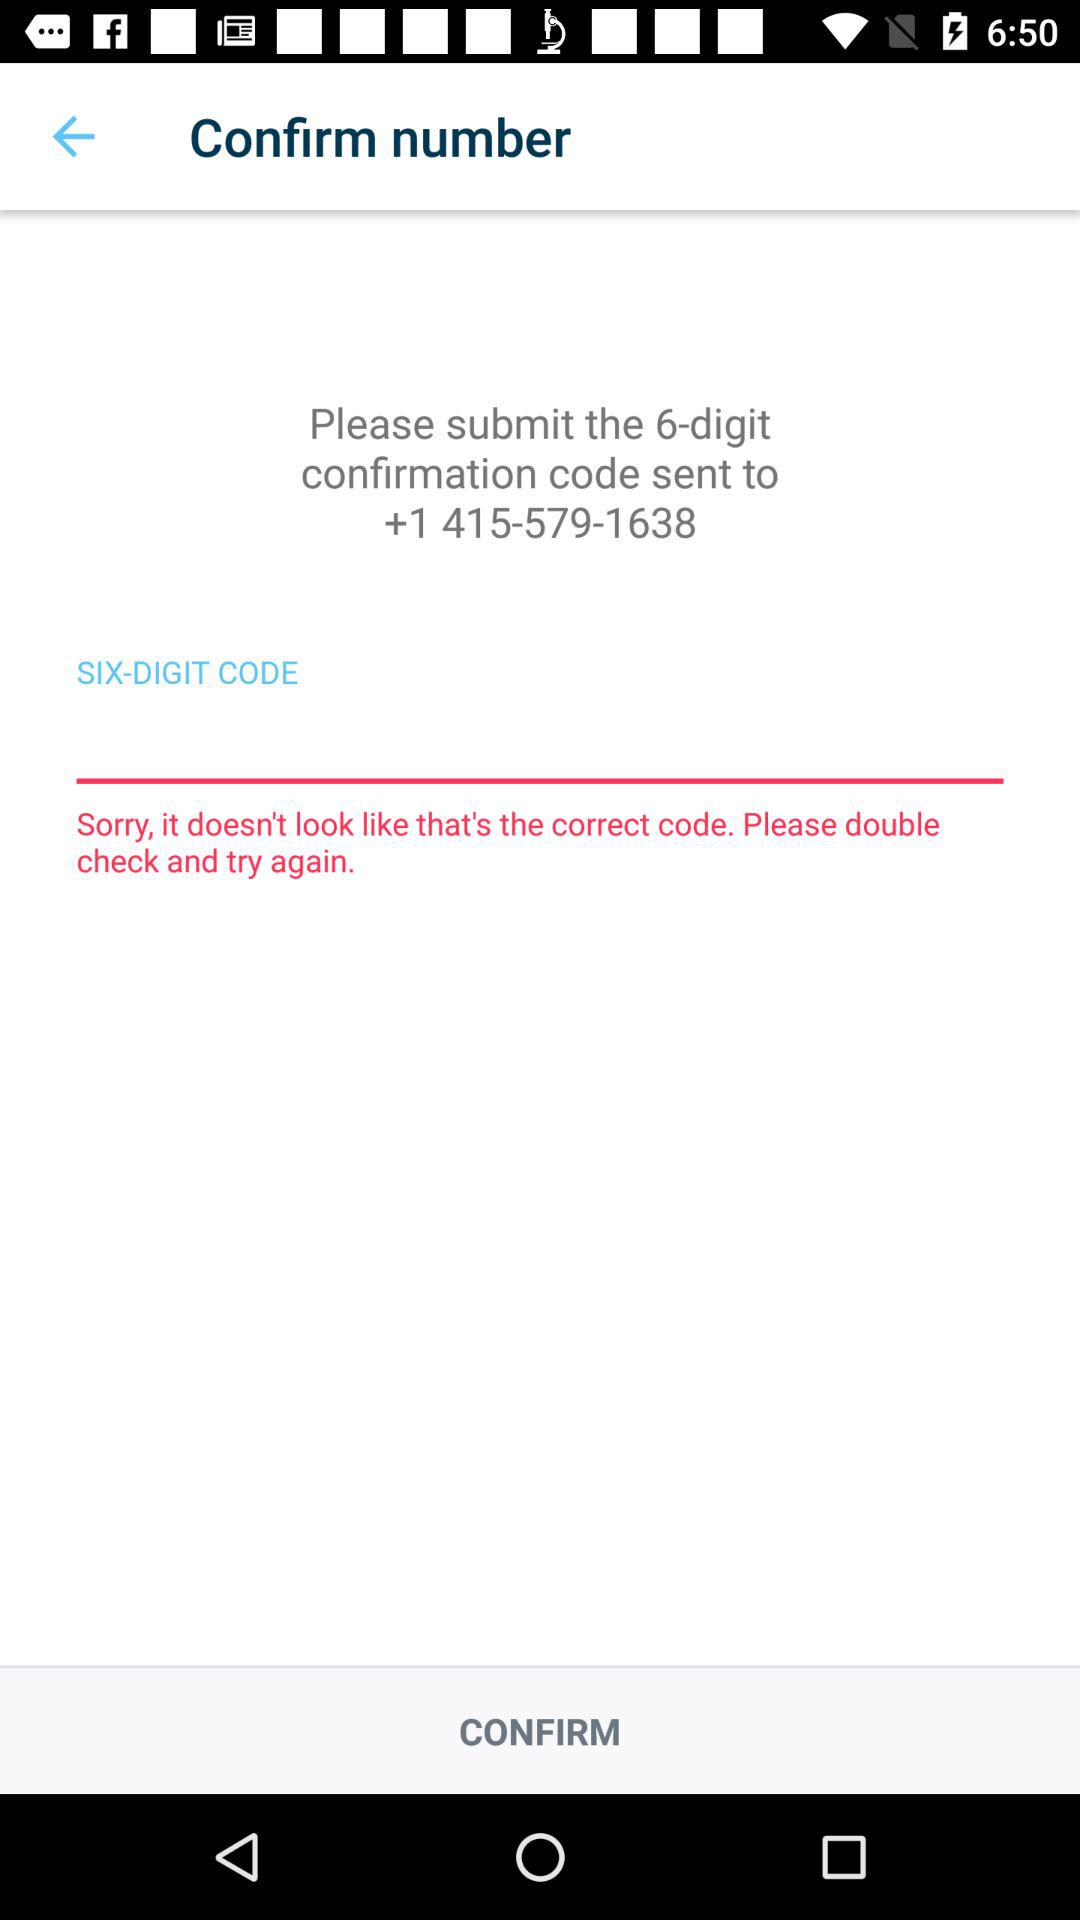What's the country code? The country's code is +1. 